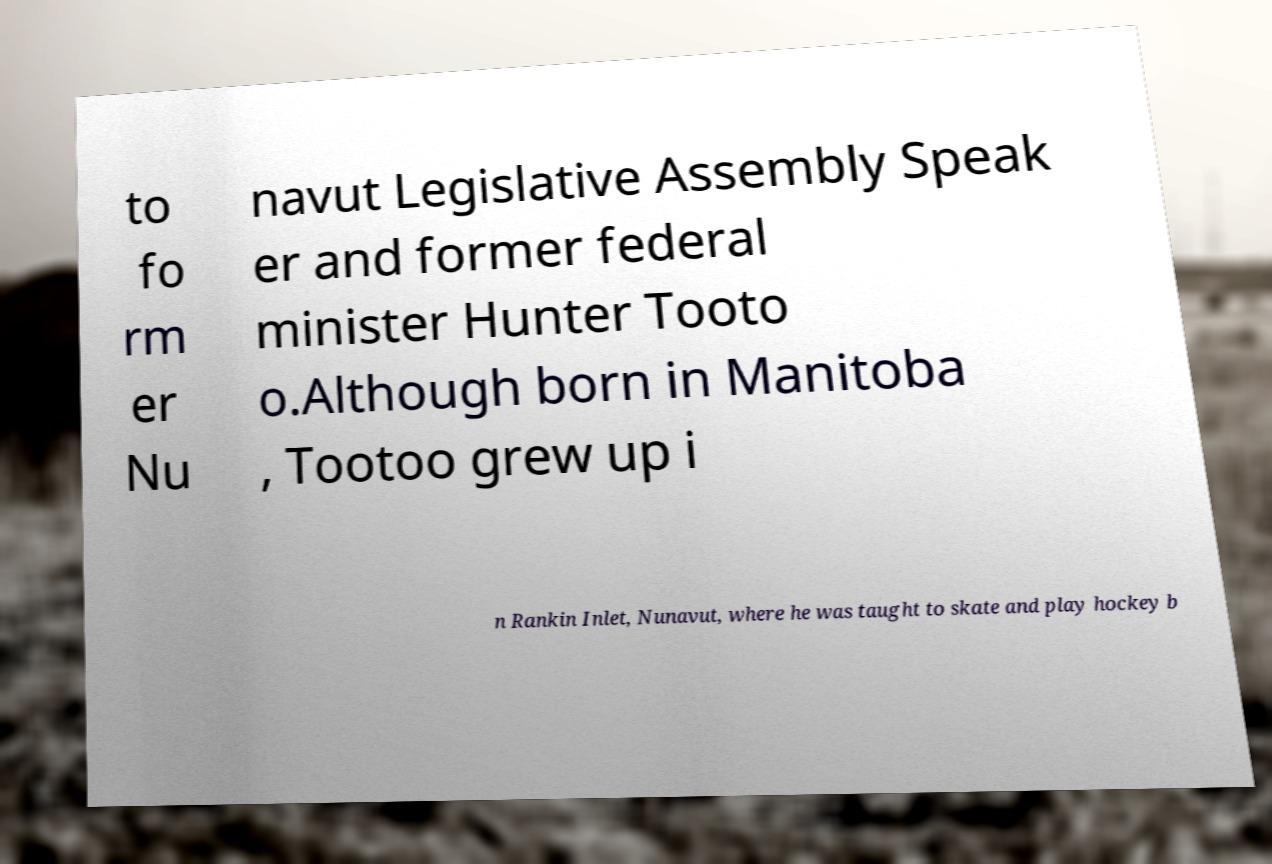What messages or text are displayed in this image? I need them in a readable, typed format. to fo rm er Nu navut Legislative Assembly Speak er and former federal minister Hunter Tooto o.Although born in Manitoba , Tootoo grew up i n Rankin Inlet, Nunavut, where he was taught to skate and play hockey b 